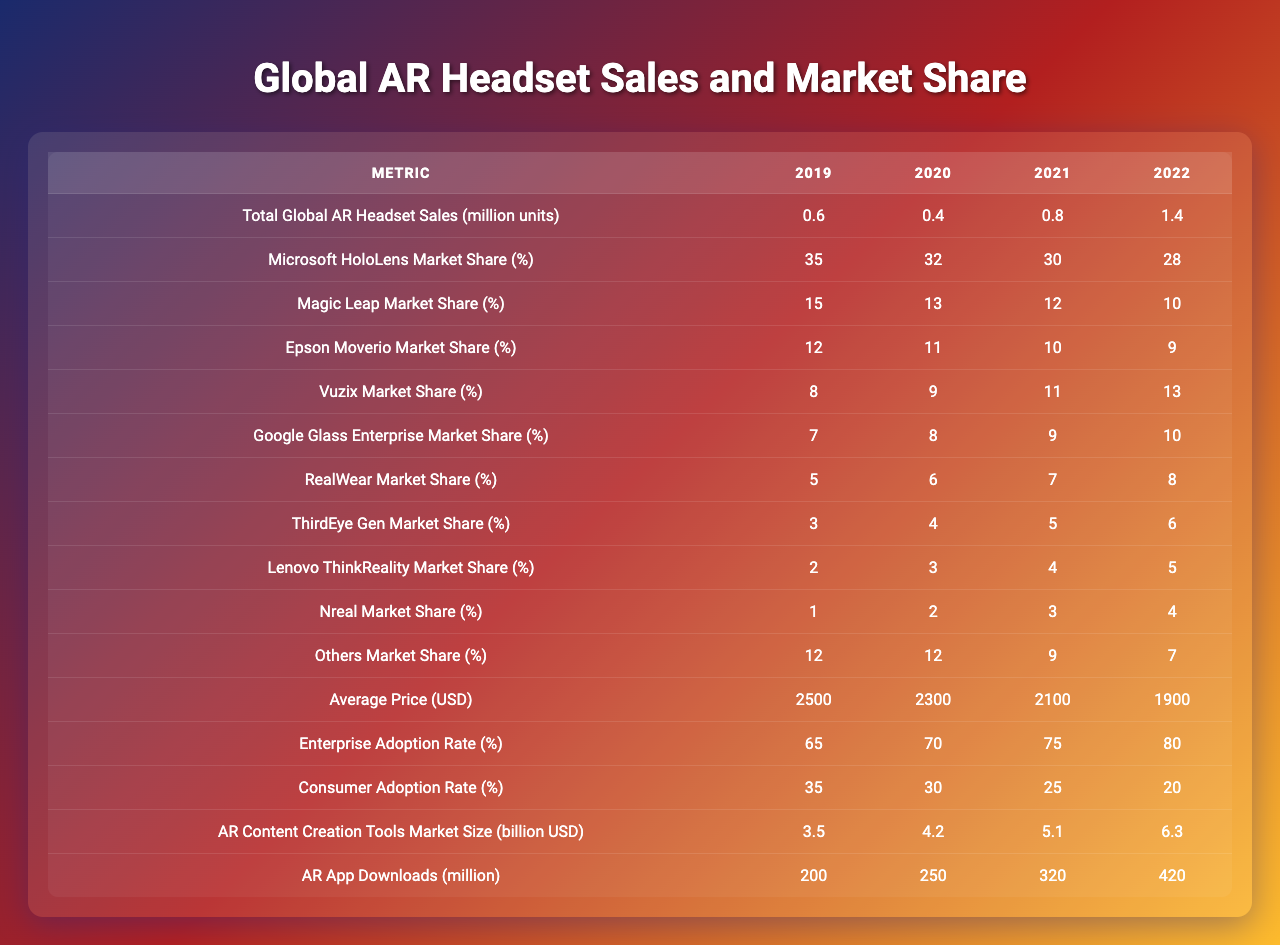What was the total global AR headset sales in 2022? In 2022, the table shows that the total global AR headset sales were 1.4 million units.
Answer: 1.4 million units Which manufacturer had the highest market share in 2019? Looking at the table for the year 2019, Microsoft HoloLens had the highest market share at 35%.
Answer: Microsoft HoloLens What was the average price of AR headsets in 2021? The table states that the average price of AR headsets in 2021 was $2100.
Answer: $2100 In which year did Vuzix have the highest market share? The data indicates that Vuzix had its highest market share of 13% in 2022.
Answer: 2022 What is the percentage difference in Microsoft HoloLens market share from 2019 to 2022? In 2019, the market share was 35%, and in 2022 it is 28%. The difference is 35% - 28% = 7%.
Answer: 7% Which year had the lowest consumer adoption rate, and what was it? The table shows that the consumer adoption rate was lowest in 2022 at 20%.
Answer: 2022, 20% What was the total AR content creation tools market size in 2020? According to the table, the market size for AR content creation tools in 2020 was $4.2 billion.
Answer: $4.2 billion Did the overall global AR headset sales increase every year? The sales figures are 0.6, 0.4, 0.8, and 1.4 million units, showing a decline in 2020, thus the sales did not increase every year.
Answer: No What is the sum of the market shares of the top three manufacturers in 2021? The top three manufacturers in 2021 are Microsoft HoloLens (30%), Magic Leap (12%), and Epson Moverio (10%). The sum is 30% + 12% + 10% = 52%.
Answer: 52% How much did AR app downloads increase from 2019 to 2022? In 2019, AR app downloads were 200 million, and in 2022, they grew to 420 million. This is an increase of 420 million - 200 million = 220 million.
Answer: 220 million 